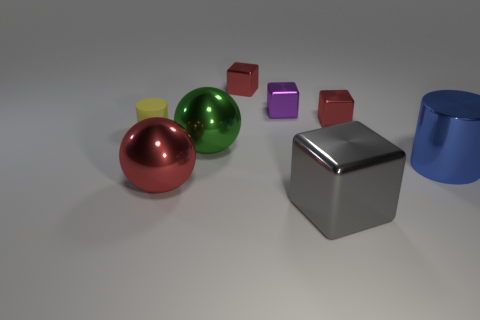Subtract all tiny purple metal cubes. How many cubes are left? 3 Subtract 3 cubes. How many cubes are left? 1 Add 2 tiny gray shiny cylinders. How many objects exist? 10 Subtract all green balls. How many balls are left? 1 Subtract all cylinders. How many objects are left? 6 Subtract all cyan cylinders. How many red cubes are left? 2 Subtract all yellow shiny cylinders. Subtract all shiny balls. How many objects are left? 6 Add 7 metallic cylinders. How many metallic cylinders are left? 8 Add 1 shiny cubes. How many shiny cubes exist? 5 Subtract 0 cyan cylinders. How many objects are left? 8 